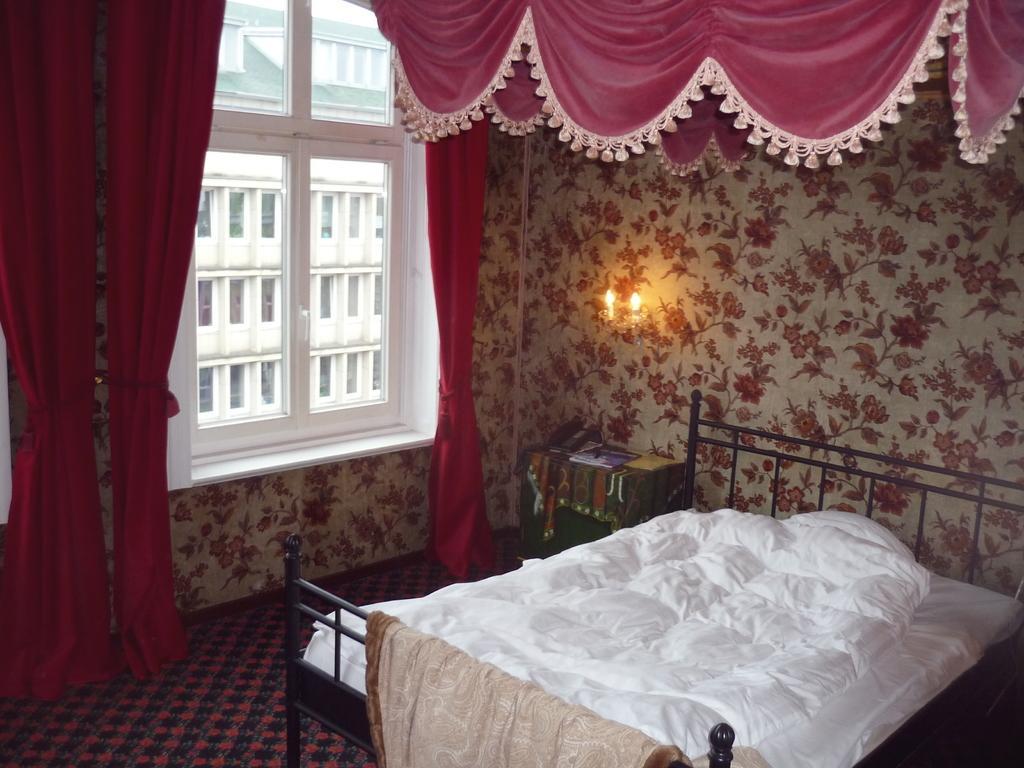How would you summarize this image in a sentence or two? In this image, we can see some curtains. There is an inside view of a room. There is a bed in the bottom right of the image. There is a window on the left side of the image. There is a light on the wall. 